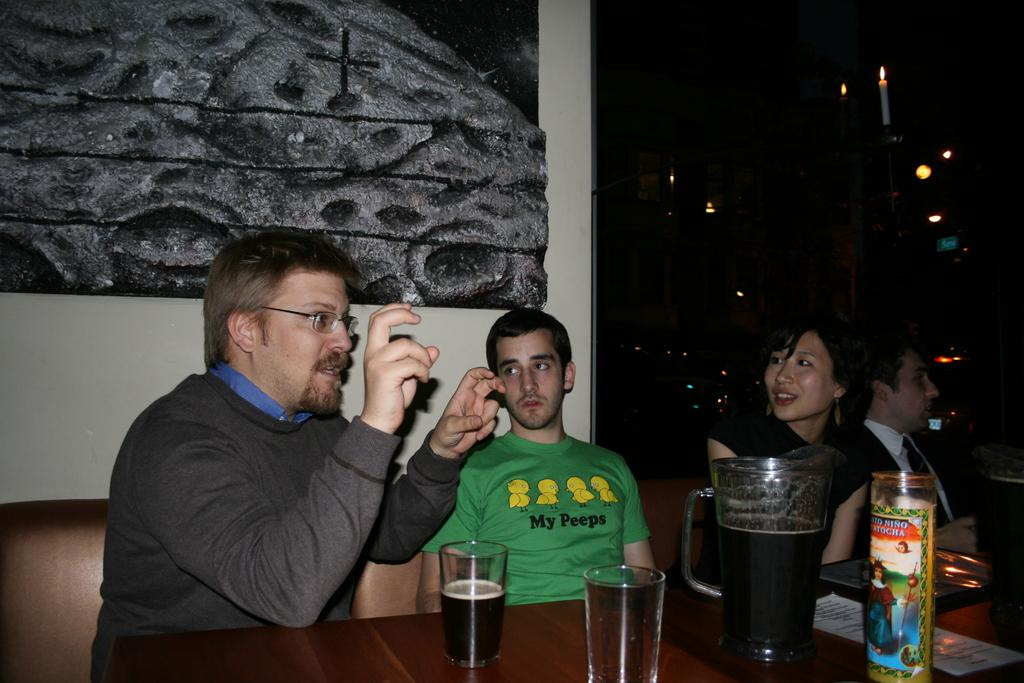Provide a one-sentence caption for the provided image. A man makes a quotes sign with his fingers while sitting next to a man wearing a t-shirt with a bird pun on it. 